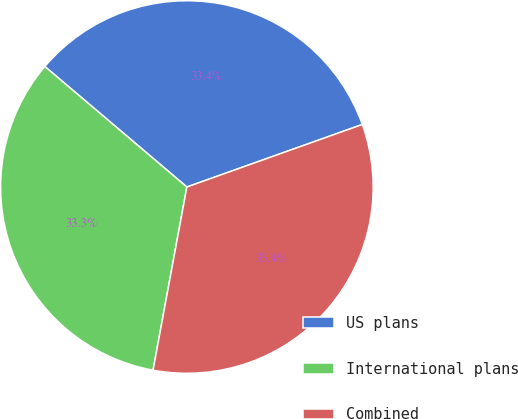Convert chart. <chart><loc_0><loc_0><loc_500><loc_500><pie_chart><fcel>US plans<fcel>International plans<fcel>Combined<nl><fcel>33.35%<fcel>33.29%<fcel>33.35%<nl></chart> 